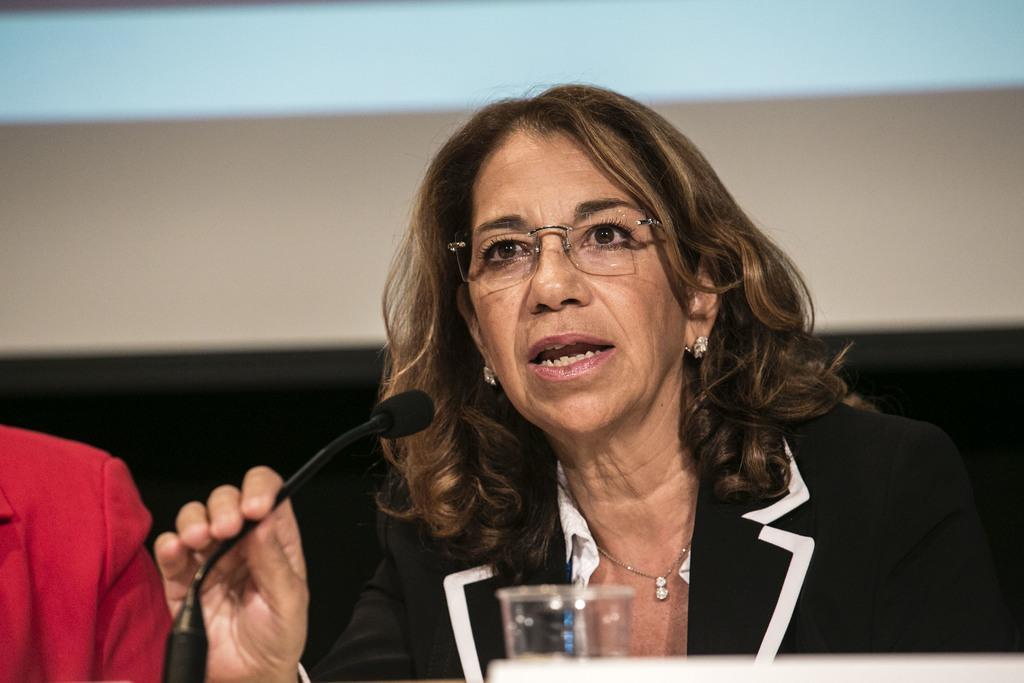How would you summarize this image in a sentence or two? As we can see in the image, there is a woman speaking on mike and wearing spectacles. In front of the women there is a glass. 